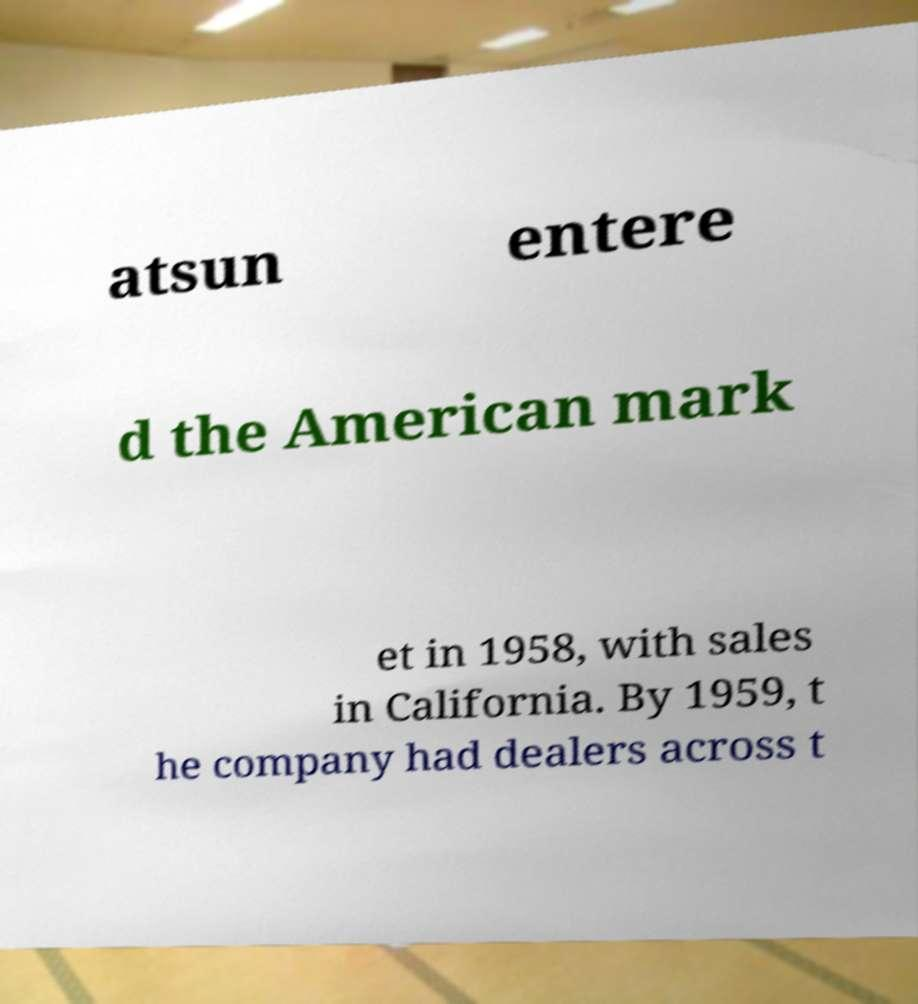Could you extract and type out the text from this image? atsun entere d the American mark et in 1958, with sales in California. By 1959, t he company had dealers across t 